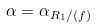Convert formula to latex. <formula><loc_0><loc_0><loc_500><loc_500>\alpha = \alpha _ { R _ { 1 } / ( f ) }</formula> 